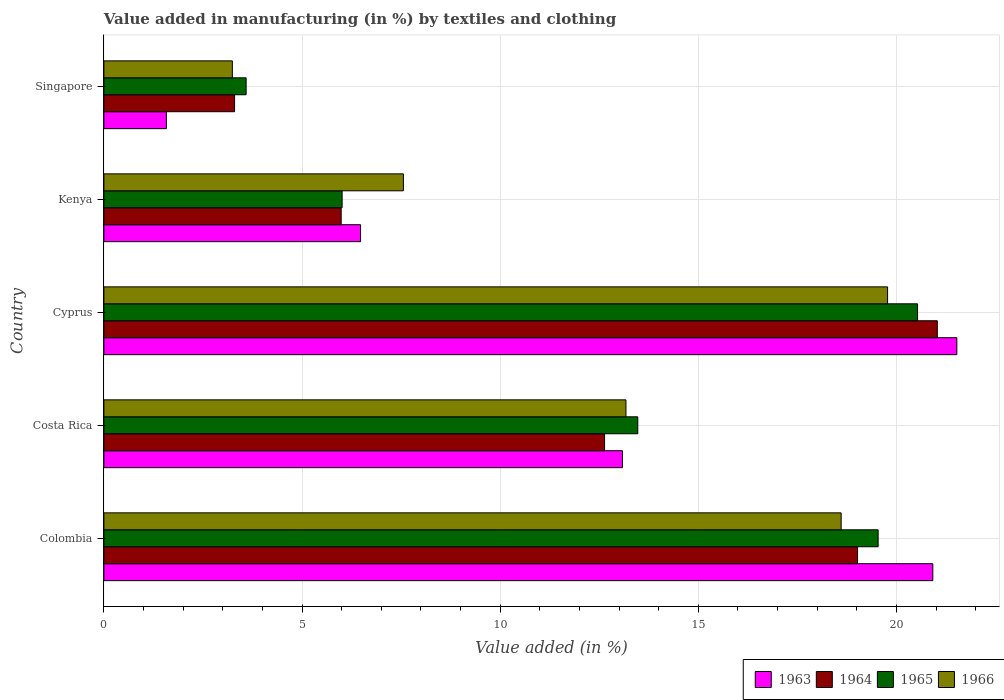Are the number of bars per tick equal to the number of legend labels?
Provide a short and direct response. Yes. How many bars are there on the 2nd tick from the bottom?
Offer a terse response. 4. What is the label of the 3rd group of bars from the top?
Provide a succinct answer. Cyprus. What is the percentage of value added in manufacturing by textiles and clothing in 1965 in Colombia?
Your response must be concise. 19.54. Across all countries, what is the maximum percentage of value added in manufacturing by textiles and clothing in 1963?
Keep it short and to the point. 21.52. Across all countries, what is the minimum percentage of value added in manufacturing by textiles and clothing in 1963?
Ensure brevity in your answer.  1.58. In which country was the percentage of value added in manufacturing by textiles and clothing in 1964 maximum?
Give a very brief answer. Cyprus. In which country was the percentage of value added in manufacturing by textiles and clothing in 1966 minimum?
Make the answer very short. Singapore. What is the total percentage of value added in manufacturing by textiles and clothing in 1963 in the graph?
Offer a very short reply. 63.58. What is the difference between the percentage of value added in manufacturing by textiles and clothing in 1963 in Costa Rica and that in Cyprus?
Provide a short and direct response. -8.44. What is the difference between the percentage of value added in manufacturing by textiles and clothing in 1964 in Cyprus and the percentage of value added in manufacturing by textiles and clothing in 1965 in Kenya?
Your answer should be very brief. 15.02. What is the average percentage of value added in manufacturing by textiles and clothing in 1963 per country?
Provide a succinct answer. 12.72. What is the difference between the percentage of value added in manufacturing by textiles and clothing in 1966 and percentage of value added in manufacturing by textiles and clothing in 1964 in Colombia?
Make the answer very short. -0.41. In how many countries, is the percentage of value added in manufacturing by textiles and clothing in 1964 greater than 3 %?
Offer a very short reply. 5. What is the ratio of the percentage of value added in manufacturing by textiles and clothing in 1963 in Costa Rica to that in Singapore?
Your response must be concise. 8.3. Is the percentage of value added in manufacturing by textiles and clothing in 1965 in Colombia less than that in Kenya?
Provide a short and direct response. No. Is the difference between the percentage of value added in manufacturing by textiles and clothing in 1966 in Costa Rica and Singapore greater than the difference between the percentage of value added in manufacturing by textiles and clothing in 1964 in Costa Rica and Singapore?
Offer a terse response. Yes. What is the difference between the highest and the second highest percentage of value added in manufacturing by textiles and clothing in 1965?
Ensure brevity in your answer.  0.99. What is the difference between the highest and the lowest percentage of value added in manufacturing by textiles and clothing in 1963?
Offer a very short reply. 19.95. In how many countries, is the percentage of value added in manufacturing by textiles and clothing in 1965 greater than the average percentage of value added in manufacturing by textiles and clothing in 1965 taken over all countries?
Provide a succinct answer. 3. What does the 2nd bar from the top in Singapore represents?
Provide a short and direct response. 1965. What does the 2nd bar from the bottom in Costa Rica represents?
Offer a very short reply. 1964. Is it the case that in every country, the sum of the percentage of value added in manufacturing by textiles and clothing in 1966 and percentage of value added in manufacturing by textiles and clothing in 1965 is greater than the percentage of value added in manufacturing by textiles and clothing in 1963?
Make the answer very short. Yes. How many bars are there?
Provide a succinct answer. 20. Are all the bars in the graph horizontal?
Offer a terse response. Yes. How many countries are there in the graph?
Provide a succinct answer. 5. Does the graph contain any zero values?
Keep it short and to the point. No. Where does the legend appear in the graph?
Your answer should be compact. Bottom right. What is the title of the graph?
Your answer should be compact. Value added in manufacturing (in %) by textiles and clothing. Does "1969" appear as one of the legend labels in the graph?
Offer a very short reply. No. What is the label or title of the X-axis?
Your response must be concise. Value added (in %). What is the label or title of the Y-axis?
Provide a succinct answer. Country. What is the Value added (in %) in 1963 in Colombia?
Give a very brief answer. 20.92. What is the Value added (in %) of 1964 in Colombia?
Make the answer very short. 19.02. What is the Value added (in %) in 1965 in Colombia?
Provide a short and direct response. 19.54. What is the Value added (in %) of 1966 in Colombia?
Ensure brevity in your answer.  18.6. What is the Value added (in %) in 1963 in Costa Rica?
Offer a terse response. 13.08. What is the Value added (in %) of 1964 in Costa Rica?
Ensure brevity in your answer.  12.63. What is the Value added (in %) of 1965 in Costa Rica?
Make the answer very short. 13.47. What is the Value added (in %) in 1966 in Costa Rica?
Give a very brief answer. 13.17. What is the Value added (in %) in 1963 in Cyprus?
Keep it short and to the point. 21.52. What is the Value added (in %) of 1964 in Cyprus?
Keep it short and to the point. 21.03. What is the Value added (in %) of 1965 in Cyprus?
Give a very brief answer. 20.53. What is the Value added (in %) of 1966 in Cyprus?
Give a very brief answer. 19.78. What is the Value added (in %) in 1963 in Kenya?
Give a very brief answer. 6.48. What is the Value added (in %) of 1964 in Kenya?
Offer a very short reply. 5.99. What is the Value added (in %) of 1965 in Kenya?
Offer a terse response. 6.01. What is the Value added (in %) in 1966 in Kenya?
Offer a very short reply. 7.56. What is the Value added (in %) of 1963 in Singapore?
Make the answer very short. 1.58. What is the Value added (in %) of 1964 in Singapore?
Your response must be concise. 3.3. What is the Value added (in %) in 1965 in Singapore?
Your answer should be very brief. 3.59. What is the Value added (in %) in 1966 in Singapore?
Give a very brief answer. 3.24. Across all countries, what is the maximum Value added (in %) of 1963?
Your response must be concise. 21.52. Across all countries, what is the maximum Value added (in %) of 1964?
Your answer should be compact. 21.03. Across all countries, what is the maximum Value added (in %) in 1965?
Ensure brevity in your answer.  20.53. Across all countries, what is the maximum Value added (in %) in 1966?
Your response must be concise. 19.78. Across all countries, what is the minimum Value added (in %) of 1963?
Keep it short and to the point. 1.58. Across all countries, what is the minimum Value added (in %) of 1964?
Provide a succinct answer. 3.3. Across all countries, what is the minimum Value added (in %) in 1965?
Make the answer very short. 3.59. Across all countries, what is the minimum Value added (in %) in 1966?
Offer a very short reply. 3.24. What is the total Value added (in %) of 1963 in the graph?
Offer a terse response. 63.58. What is the total Value added (in %) in 1964 in the graph?
Give a very brief answer. 61.97. What is the total Value added (in %) in 1965 in the graph?
Make the answer very short. 63.14. What is the total Value added (in %) in 1966 in the graph?
Give a very brief answer. 62.35. What is the difference between the Value added (in %) of 1963 in Colombia and that in Costa Rica?
Offer a very short reply. 7.83. What is the difference between the Value added (in %) of 1964 in Colombia and that in Costa Rica?
Make the answer very short. 6.38. What is the difference between the Value added (in %) in 1965 in Colombia and that in Costa Rica?
Your response must be concise. 6.06. What is the difference between the Value added (in %) of 1966 in Colombia and that in Costa Rica?
Give a very brief answer. 5.43. What is the difference between the Value added (in %) of 1963 in Colombia and that in Cyprus?
Offer a terse response. -0.61. What is the difference between the Value added (in %) of 1964 in Colombia and that in Cyprus?
Your answer should be very brief. -2.01. What is the difference between the Value added (in %) in 1965 in Colombia and that in Cyprus?
Keep it short and to the point. -0.99. What is the difference between the Value added (in %) in 1966 in Colombia and that in Cyprus?
Provide a succinct answer. -1.17. What is the difference between the Value added (in %) in 1963 in Colombia and that in Kenya?
Offer a terse response. 14.44. What is the difference between the Value added (in %) in 1964 in Colombia and that in Kenya?
Offer a terse response. 13.03. What is the difference between the Value added (in %) in 1965 in Colombia and that in Kenya?
Offer a very short reply. 13.53. What is the difference between the Value added (in %) in 1966 in Colombia and that in Kenya?
Make the answer very short. 11.05. What is the difference between the Value added (in %) of 1963 in Colombia and that in Singapore?
Your answer should be very brief. 19.34. What is the difference between the Value added (in %) in 1964 in Colombia and that in Singapore?
Make the answer very short. 15.72. What is the difference between the Value added (in %) in 1965 in Colombia and that in Singapore?
Keep it short and to the point. 15.95. What is the difference between the Value added (in %) of 1966 in Colombia and that in Singapore?
Your response must be concise. 15.36. What is the difference between the Value added (in %) of 1963 in Costa Rica and that in Cyprus?
Your answer should be very brief. -8.44. What is the difference between the Value added (in %) in 1964 in Costa Rica and that in Cyprus?
Make the answer very short. -8.4. What is the difference between the Value added (in %) in 1965 in Costa Rica and that in Cyprus?
Offer a terse response. -7.06. What is the difference between the Value added (in %) in 1966 in Costa Rica and that in Cyprus?
Your answer should be very brief. -6.6. What is the difference between the Value added (in %) of 1963 in Costa Rica and that in Kenya?
Give a very brief answer. 6.61. What is the difference between the Value added (in %) of 1964 in Costa Rica and that in Kenya?
Provide a succinct answer. 6.65. What is the difference between the Value added (in %) of 1965 in Costa Rica and that in Kenya?
Keep it short and to the point. 7.46. What is the difference between the Value added (in %) of 1966 in Costa Rica and that in Kenya?
Give a very brief answer. 5.62. What is the difference between the Value added (in %) of 1963 in Costa Rica and that in Singapore?
Ensure brevity in your answer.  11.51. What is the difference between the Value added (in %) in 1964 in Costa Rica and that in Singapore?
Make the answer very short. 9.34. What is the difference between the Value added (in %) of 1965 in Costa Rica and that in Singapore?
Provide a succinct answer. 9.88. What is the difference between the Value added (in %) of 1966 in Costa Rica and that in Singapore?
Your answer should be very brief. 9.93. What is the difference between the Value added (in %) in 1963 in Cyprus and that in Kenya?
Provide a succinct answer. 15.05. What is the difference between the Value added (in %) in 1964 in Cyprus and that in Kenya?
Offer a terse response. 15.04. What is the difference between the Value added (in %) in 1965 in Cyprus and that in Kenya?
Give a very brief answer. 14.52. What is the difference between the Value added (in %) of 1966 in Cyprus and that in Kenya?
Offer a very short reply. 12.22. What is the difference between the Value added (in %) of 1963 in Cyprus and that in Singapore?
Make the answer very short. 19.95. What is the difference between the Value added (in %) of 1964 in Cyprus and that in Singapore?
Keep it short and to the point. 17.73. What is the difference between the Value added (in %) of 1965 in Cyprus and that in Singapore?
Make the answer very short. 16.94. What is the difference between the Value added (in %) in 1966 in Cyprus and that in Singapore?
Your answer should be very brief. 16.53. What is the difference between the Value added (in %) of 1963 in Kenya and that in Singapore?
Make the answer very short. 4.9. What is the difference between the Value added (in %) in 1964 in Kenya and that in Singapore?
Your response must be concise. 2.69. What is the difference between the Value added (in %) in 1965 in Kenya and that in Singapore?
Provide a succinct answer. 2.42. What is the difference between the Value added (in %) in 1966 in Kenya and that in Singapore?
Offer a terse response. 4.32. What is the difference between the Value added (in %) of 1963 in Colombia and the Value added (in %) of 1964 in Costa Rica?
Make the answer very short. 8.28. What is the difference between the Value added (in %) of 1963 in Colombia and the Value added (in %) of 1965 in Costa Rica?
Ensure brevity in your answer.  7.44. What is the difference between the Value added (in %) in 1963 in Colombia and the Value added (in %) in 1966 in Costa Rica?
Provide a short and direct response. 7.74. What is the difference between the Value added (in %) in 1964 in Colombia and the Value added (in %) in 1965 in Costa Rica?
Your answer should be very brief. 5.55. What is the difference between the Value added (in %) of 1964 in Colombia and the Value added (in %) of 1966 in Costa Rica?
Offer a very short reply. 5.84. What is the difference between the Value added (in %) in 1965 in Colombia and the Value added (in %) in 1966 in Costa Rica?
Provide a succinct answer. 6.36. What is the difference between the Value added (in %) of 1963 in Colombia and the Value added (in %) of 1964 in Cyprus?
Your response must be concise. -0.11. What is the difference between the Value added (in %) of 1963 in Colombia and the Value added (in %) of 1965 in Cyprus?
Offer a very short reply. 0.39. What is the difference between the Value added (in %) of 1963 in Colombia and the Value added (in %) of 1966 in Cyprus?
Give a very brief answer. 1.14. What is the difference between the Value added (in %) in 1964 in Colombia and the Value added (in %) in 1965 in Cyprus?
Your answer should be very brief. -1.51. What is the difference between the Value added (in %) of 1964 in Colombia and the Value added (in %) of 1966 in Cyprus?
Make the answer very short. -0.76. What is the difference between the Value added (in %) of 1965 in Colombia and the Value added (in %) of 1966 in Cyprus?
Your answer should be very brief. -0.24. What is the difference between the Value added (in %) of 1963 in Colombia and the Value added (in %) of 1964 in Kenya?
Give a very brief answer. 14.93. What is the difference between the Value added (in %) in 1963 in Colombia and the Value added (in %) in 1965 in Kenya?
Make the answer very short. 14.91. What is the difference between the Value added (in %) of 1963 in Colombia and the Value added (in %) of 1966 in Kenya?
Provide a succinct answer. 13.36. What is the difference between the Value added (in %) in 1964 in Colombia and the Value added (in %) in 1965 in Kenya?
Your response must be concise. 13.01. What is the difference between the Value added (in %) of 1964 in Colombia and the Value added (in %) of 1966 in Kenya?
Offer a very short reply. 11.46. What is the difference between the Value added (in %) of 1965 in Colombia and the Value added (in %) of 1966 in Kenya?
Your answer should be very brief. 11.98. What is the difference between the Value added (in %) of 1963 in Colombia and the Value added (in %) of 1964 in Singapore?
Offer a terse response. 17.62. What is the difference between the Value added (in %) of 1963 in Colombia and the Value added (in %) of 1965 in Singapore?
Keep it short and to the point. 17.33. What is the difference between the Value added (in %) in 1963 in Colombia and the Value added (in %) in 1966 in Singapore?
Your answer should be very brief. 17.68. What is the difference between the Value added (in %) in 1964 in Colombia and the Value added (in %) in 1965 in Singapore?
Give a very brief answer. 15.43. What is the difference between the Value added (in %) in 1964 in Colombia and the Value added (in %) in 1966 in Singapore?
Keep it short and to the point. 15.78. What is the difference between the Value added (in %) of 1965 in Colombia and the Value added (in %) of 1966 in Singapore?
Your response must be concise. 16.3. What is the difference between the Value added (in %) in 1963 in Costa Rica and the Value added (in %) in 1964 in Cyprus?
Keep it short and to the point. -7.95. What is the difference between the Value added (in %) in 1963 in Costa Rica and the Value added (in %) in 1965 in Cyprus?
Ensure brevity in your answer.  -7.45. What is the difference between the Value added (in %) of 1963 in Costa Rica and the Value added (in %) of 1966 in Cyprus?
Offer a very short reply. -6.69. What is the difference between the Value added (in %) of 1964 in Costa Rica and the Value added (in %) of 1965 in Cyprus?
Your answer should be very brief. -7.9. What is the difference between the Value added (in %) of 1964 in Costa Rica and the Value added (in %) of 1966 in Cyprus?
Your answer should be very brief. -7.14. What is the difference between the Value added (in %) in 1965 in Costa Rica and the Value added (in %) in 1966 in Cyprus?
Offer a terse response. -6.3. What is the difference between the Value added (in %) of 1963 in Costa Rica and the Value added (in %) of 1964 in Kenya?
Keep it short and to the point. 7.1. What is the difference between the Value added (in %) of 1963 in Costa Rica and the Value added (in %) of 1965 in Kenya?
Your answer should be very brief. 7.07. What is the difference between the Value added (in %) of 1963 in Costa Rica and the Value added (in %) of 1966 in Kenya?
Your response must be concise. 5.53. What is the difference between the Value added (in %) of 1964 in Costa Rica and the Value added (in %) of 1965 in Kenya?
Give a very brief answer. 6.62. What is the difference between the Value added (in %) of 1964 in Costa Rica and the Value added (in %) of 1966 in Kenya?
Provide a short and direct response. 5.08. What is the difference between the Value added (in %) in 1965 in Costa Rica and the Value added (in %) in 1966 in Kenya?
Give a very brief answer. 5.91. What is the difference between the Value added (in %) in 1963 in Costa Rica and the Value added (in %) in 1964 in Singapore?
Offer a terse response. 9.79. What is the difference between the Value added (in %) in 1963 in Costa Rica and the Value added (in %) in 1965 in Singapore?
Give a very brief answer. 9.5. What is the difference between the Value added (in %) of 1963 in Costa Rica and the Value added (in %) of 1966 in Singapore?
Offer a very short reply. 9.84. What is the difference between the Value added (in %) in 1964 in Costa Rica and the Value added (in %) in 1965 in Singapore?
Make the answer very short. 9.04. What is the difference between the Value added (in %) in 1964 in Costa Rica and the Value added (in %) in 1966 in Singapore?
Your answer should be compact. 9.39. What is the difference between the Value added (in %) in 1965 in Costa Rica and the Value added (in %) in 1966 in Singapore?
Give a very brief answer. 10.23. What is the difference between the Value added (in %) in 1963 in Cyprus and the Value added (in %) in 1964 in Kenya?
Your answer should be compact. 15.54. What is the difference between the Value added (in %) in 1963 in Cyprus and the Value added (in %) in 1965 in Kenya?
Your answer should be very brief. 15.51. What is the difference between the Value added (in %) of 1963 in Cyprus and the Value added (in %) of 1966 in Kenya?
Your response must be concise. 13.97. What is the difference between the Value added (in %) in 1964 in Cyprus and the Value added (in %) in 1965 in Kenya?
Ensure brevity in your answer.  15.02. What is the difference between the Value added (in %) in 1964 in Cyprus and the Value added (in %) in 1966 in Kenya?
Provide a succinct answer. 13.47. What is the difference between the Value added (in %) in 1965 in Cyprus and the Value added (in %) in 1966 in Kenya?
Offer a very short reply. 12.97. What is the difference between the Value added (in %) in 1963 in Cyprus and the Value added (in %) in 1964 in Singapore?
Your response must be concise. 18.23. What is the difference between the Value added (in %) in 1963 in Cyprus and the Value added (in %) in 1965 in Singapore?
Provide a succinct answer. 17.93. What is the difference between the Value added (in %) of 1963 in Cyprus and the Value added (in %) of 1966 in Singapore?
Make the answer very short. 18.28. What is the difference between the Value added (in %) of 1964 in Cyprus and the Value added (in %) of 1965 in Singapore?
Give a very brief answer. 17.44. What is the difference between the Value added (in %) of 1964 in Cyprus and the Value added (in %) of 1966 in Singapore?
Offer a terse response. 17.79. What is the difference between the Value added (in %) of 1965 in Cyprus and the Value added (in %) of 1966 in Singapore?
Your answer should be very brief. 17.29. What is the difference between the Value added (in %) in 1963 in Kenya and the Value added (in %) in 1964 in Singapore?
Give a very brief answer. 3.18. What is the difference between the Value added (in %) of 1963 in Kenya and the Value added (in %) of 1965 in Singapore?
Make the answer very short. 2.89. What is the difference between the Value added (in %) in 1963 in Kenya and the Value added (in %) in 1966 in Singapore?
Ensure brevity in your answer.  3.24. What is the difference between the Value added (in %) of 1964 in Kenya and the Value added (in %) of 1965 in Singapore?
Provide a succinct answer. 2.4. What is the difference between the Value added (in %) in 1964 in Kenya and the Value added (in %) in 1966 in Singapore?
Your response must be concise. 2.75. What is the difference between the Value added (in %) in 1965 in Kenya and the Value added (in %) in 1966 in Singapore?
Make the answer very short. 2.77. What is the average Value added (in %) of 1963 per country?
Your response must be concise. 12.72. What is the average Value added (in %) in 1964 per country?
Make the answer very short. 12.39. What is the average Value added (in %) in 1965 per country?
Ensure brevity in your answer.  12.63. What is the average Value added (in %) in 1966 per country?
Your response must be concise. 12.47. What is the difference between the Value added (in %) in 1963 and Value added (in %) in 1964 in Colombia?
Provide a succinct answer. 1.9. What is the difference between the Value added (in %) in 1963 and Value added (in %) in 1965 in Colombia?
Make the answer very short. 1.38. What is the difference between the Value added (in %) of 1963 and Value added (in %) of 1966 in Colombia?
Your answer should be very brief. 2.31. What is the difference between the Value added (in %) of 1964 and Value added (in %) of 1965 in Colombia?
Give a very brief answer. -0.52. What is the difference between the Value added (in %) of 1964 and Value added (in %) of 1966 in Colombia?
Provide a short and direct response. 0.41. What is the difference between the Value added (in %) of 1965 and Value added (in %) of 1966 in Colombia?
Make the answer very short. 0.93. What is the difference between the Value added (in %) of 1963 and Value added (in %) of 1964 in Costa Rica?
Keep it short and to the point. 0.45. What is the difference between the Value added (in %) of 1963 and Value added (in %) of 1965 in Costa Rica?
Offer a very short reply. -0.39. What is the difference between the Value added (in %) in 1963 and Value added (in %) in 1966 in Costa Rica?
Ensure brevity in your answer.  -0.09. What is the difference between the Value added (in %) in 1964 and Value added (in %) in 1965 in Costa Rica?
Your response must be concise. -0.84. What is the difference between the Value added (in %) of 1964 and Value added (in %) of 1966 in Costa Rica?
Give a very brief answer. -0.54. What is the difference between the Value added (in %) in 1965 and Value added (in %) in 1966 in Costa Rica?
Provide a short and direct response. 0.3. What is the difference between the Value added (in %) of 1963 and Value added (in %) of 1964 in Cyprus?
Your answer should be compact. 0.49. What is the difference between the Value added (in %) of 1963 and Value added (in %) of 1965 in Cyprus?
Ensure brevity in your answer.  0.99. What is the difference between the Value added (in %) in 1963 and Value added (in %) in 1966 in Cyprus?
Keep it short and to the point. 1.75. What is the difference between the Value added (in %) of 1964 and Value added (in %) of 1965 in Cyprus?
Your answer should be very brief. 0.5. What is the difference between the Value added (in %) in 1964 and Value added (in %) in 1966 in Cyprus?
Provide a short and direct response. 1.25. What is the difference between the Value added (in %) of 1965 and Value added (in %) of 1966 in Cyprus?
Provide a short and direct response. 0.76. What is the difference between the Value added (in %) in 1963 and Value added (in %) in 1964 in Kenya?
Give a very brief answer. 0.49. What is the difference between the Value added (in %) of 1963 and Value added (in %) of 1965 in Kenya?
Your answer should be compact. 0.47. What is the difference between the Value added (in %) of 1963 and Value added (in %) of 1966 in Kenya?
Provide a short and direct response. -1.08. What is the difference between the Value added (in %) in 1964 and Value added (in %) in 1965 in Kenya?
Your answer should be very brief. -0.02. What is the difference between the Value added (in %) in 1964 and Value added (in %) in 1966 in Kenya?
Provide a succinct answer. -1.57. What is the difference between the Value added (in %) in 1965 and Value added (in %) in 1966 in Kenya?
Offer a terse response. -1.55. What is the difference between the Value added (in %) of 1963 and Value added (in %) of 1964 in Singapore?
Make the answer very short. -1.72. What is the difference between the Value added (in %) in 1963 and Value added (in %) in 1965 in Singapore?
Ensure brevity in your answer.  -2.01. What is the difference between the Value added (in %) of 1963 and Value added (in %) of 1966 in Singapore?
Keep it short and to the point. -1.66. What is the difference between the Value added (in %) in 1964 and Value added (in %) in 1965 in Singapore?
Your answer should be compact. -0.29. What is the difference between the Value added (in %) in 1964 and Value added (in %) in 1966 in Singapore?
Provide a short and direct response. 0.06. What is the difference between the Value added (in %) of 1965 and Value added (in %) of 1966 in Singapore?
Offer a very short reply. 0.35. What is the ratio of the Value added (in %) of 1963 in Colombia to that in Costa Rica?
Offer a terse response. 1.6. What is the ratio of the Value added (in %) in 1964 in Colombia to that in Costa Rica?
Offer a terse response. 1.51. What is the ratio of the Value added (in %) of 1965 in Colombia to that in Costa Rica?
Your answer should be compact. 1.45. What is the ratio of the Value added (in %) in 1966 in Colombia to that in Costa Rica?
Offer a very short reply. 1.41. What is the ratio of the Value added (in %) of 1963 in Colombia to that in Cyprus?
Offer a terse response. 0.97. What is the ratio of the Value added (in %) of 1964 in Colombia to that in Cyprus?
Make the answer very short. 0.9. What is the ratio of the Value added (in %) of 1965 in Colombia to that in Cyprus?
Offer a terse response. 0.95. What is the ratio of the Value added (in %) in 1966 in Colombia to that in Cyprus?
Keep it short and to the point. 0.94. What is the ratio of the Value added (in %) in 1963 in Colombia to that in Kenya?
Your answer should be very brief. 3.23. What is the ratio of the Value added (in %) of 1964 in Colombia to that in Kenya?
Ensure brevity in your answer.  3.18. What is the ratio of the Value added (in %) in 1966 in Colombia to that in Kenya?
Provide a short and direct response. 2.46. What is the ratio of the Value added (in %) of 1963 in Colombia to that in Singapore?
Offer a terse response. 13.26. What is the ratio of the Value added (in %) in 1964 in Colombia to that in Singapore?
Make the answer very short. 5.77. What is the ratio of the Value added (in %) in 1965 in Colombia to that in Singapore?
Give a very brief answer. 5.44. What is the ratio of the Value added (in %) in 1966 in Colombia to that in Singapore?
Provide a short and direct response. 5.74. What is the ratio of the Value added (in %) in 1963 in Costa Rica to that in Cyprus?
Your answer should be very brief. 0.61. What is the ratio of the Value added (in %) in 1964 in Costa Rica to that in Cyprus?
Your answer should be very brief. 0.6. What is the ratio of the Value added (in %) in 1965 in Costa Rica to that in Cyprus?
Offer a terse response. 0.66. What is the ratio of the Value added (in %) in 1966 in Costa Rica to that in Cyprus?
Your answer should be compact. 0.67. What is the ratio of the Value added (in %) in 1963 in Costa Rica to that in Kenya?
Your answer should be compact. 2.02. What is the ratio of the Value added (in %) of 1964 in Costa Rica to that in Kenya?
Keep it short and to the point. 2.11. What is the ratio of the Value added (in %) of 1965 in Costa Rica to that in Kenya?
Keep it short and to the point. 2.24. What is the ratio of the Value added (in %) of 1966 in Costa Rica to that in Kenya?
Offer a terse response. 1.74. What is the ratio of the Value added (in %) in 1963 in Costa Rica to that in Singapore?
Provide a succinct answer. 8.3. What is the ratio of the Value added (in %) of 1964 in Costa Rica to that in Singapore?
Ensure brevity in your answer.  3.83. What is the ratio of the Value added (in %) of 1965 in Costa Rica to that in Singapore?
Your response must be concise. 3.75. What is the ratio of the Value added (in %) of 1966 in Costa Rica to that in Singapore?
Your answer should be compact. 4.06. What is the ratio of the Value added (in %) of 1963 in Cyprus to that in Kenya?
Your answer should be very brief. 3.32. What is the ratio of the Value added (in %) in 1964 in Cyprus to that in Kenya?
Keep it short and to the point. 3.51. What is the ratio of the Value added (in %) of 1965 in Cyprus to that in Kenya?
Give a very brief answer. 3.42. What is the ratio of the Value added (in %) in 1966 in Cyprus to that in Kenya?
Provide a succinct answer. 2.62. What is the ratio of the Value added (in %) of 1963 in Cyprus to that in Singapore?
Your answer should be very brief. 13.65. What is the ratio of the Value added (in %) in 1964 in Cyprus to that in Singapore?
Give a very brief answer. 6.38. What is the ratio of the Value added (in %) in 1965 in Cyprus to that in Singapore?
Your answer should be compact. 5.72. What is the ratio of the Value added (in %) in 1966 in Cyprus to that in Singapore?
Keep it short and to the point. 6.1. What is the ratio of the Value added (in %) of 1963 in Kenya to that in Singapore?
Ensure brevity in your answer.  4.11. What is the ratio of the Value added (in %) of 1964 in Kenya to that in Singapore?
Make the answer very short. 1.82. What is the ratio of the Value added (in %) in 1965 in Kenya to that in Singapore?
Your answer should be compact. 1.67. What is the ratio of the Value added (in %) in 1966 in Kenya to that in Singapore?
Provide a short and direct response. 2.33. What is the difference between the highest and the second highest Value added (in %) of 1963?
Provide a succinct answer. 0.61. What is the difference between the highest and the second highest Value added (in %) of 1964?
Offer a terse response. 2.01. What is the difference between the highest and the second highest Value added (in %) in 1965?
Your answer should be very brief. 0.99. What is the difference between the highest and the second highest Value added (in %) of 1966?
Your answer should be compact. 1.17. What is the difference between the highest and the lowest Value added (in %) in 1963?
Offer a very short reply. 19.95. What is the difference between the highest and the lowest Value added (in %) of 1964?
Your answer should be compact. 17.73. What is the difference between the highest and the lowest Value added (in %) in 1965?
Offer a terse response. 16.94. What is the difference between the highest and the lowest Value added (in %) of 1966?
Provide a succinct answer. 16.53. 